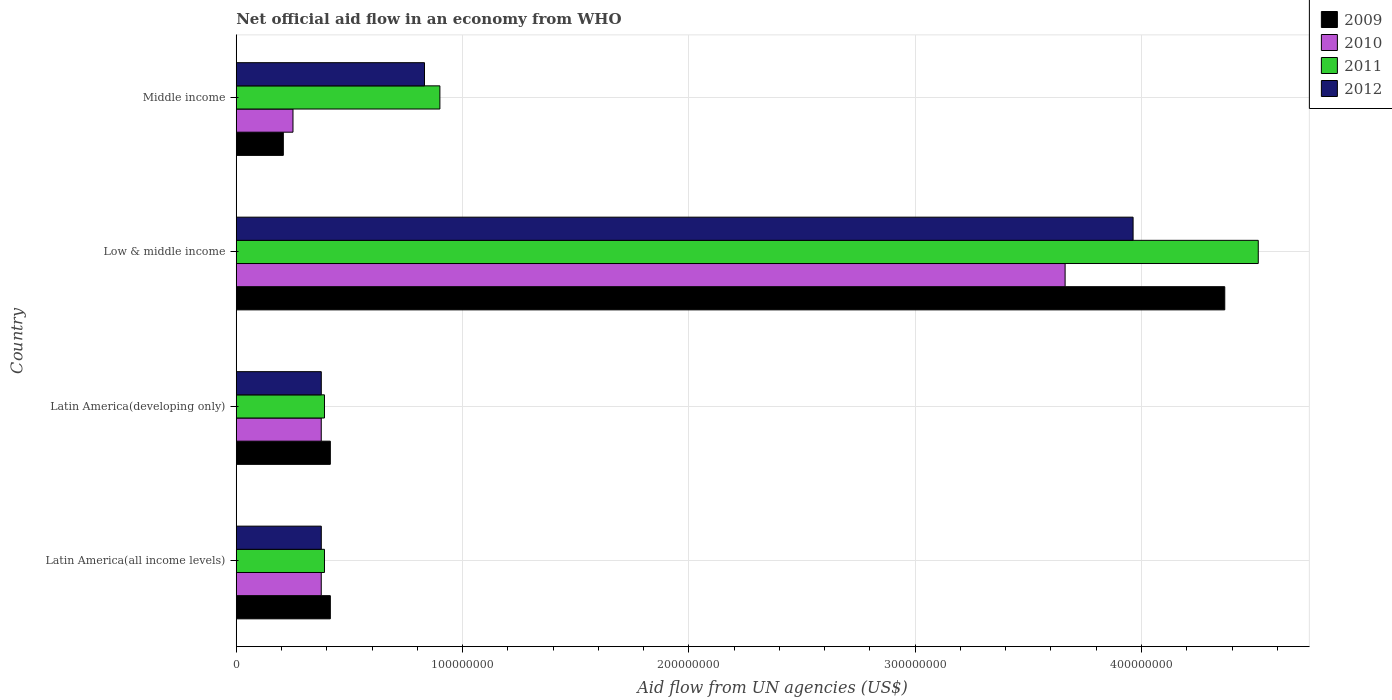How many different coloured bars are there?
Provide a succinct answer. 4. Are the number of bars on each tick of the Y-axis equal?
Give a very brief answer. Yes. How many bars are there on the 4th tick from the top?
Offer a very short reply. 4. How many bars are there on the 3rd tick from the bottom?
Offer a terse response. 4. What is the net official aid flow in 2012 in Latin America(all income levels)?
Ensure brevity in your answer.  3.76e+07. Across all countries, what is the maximum net official aid flow in 2011?
Your answer should be very brief. 4.52e+08. Across all countries, what is the minimum net official aid flow in 2009?
Provide a succinct answer. 2.08e+07. In which country was the net official aid flow in 2010 maximum?
Provide a short and direct response. Low & middle income. In which country was the net official aid flow in 2012 minimum?
Your response must be concise. Latin America(all income levels). What is the total net official aid flow in 2011 in the graph?
Your answer should be compact. 6.20e+08. What is the difference between the net official aid flow in 2012 in Latin America(all income levels) and that in Latin America(developing only)?
Your response must be concise. 0. What is the difference between the net official aid flow in 2012 in Latin America(developing only) and the net official aid flow in 2011 in Middle income?
Your answer should be very brief. -5.24e+07. What is the average net official aid flow in 2009 per country?
Offer a terse response. 1.35e+08. What is the difference between the net official aid flow in 2011 and net official aid flow in 2009 in Latin America(all income levels)?
Offer a terse response. -2.59e+06. What is the ratio of the net official aid flow in 2010 in Low & middle income to that in Middle income?
Provide a succinct answer. 14.61. Is the difference between the net official aid flow in 2011 in Low & middle income and Middle income greater than the difference between the net official aid flow in 2009 in Low & middle income and Middle income?
Provide a succinct answer. No. What is the difference between the highest and the second highest net official aid flow in 2011?
Keep it short and to the point. 3.62e+08. What is the difference between the highest and the lowest net official aid flow in 2010?
Offer a terse response. 3.41e+08. Is the sum of the net official aid flow in 2012 in Latin America(developing only) and Low & middle income greater than the maximum net official aid flow in 2010 across all countries?
Provide a succinct answer. Yes. What does the 1st bar from the bottom in Middle income represents?
Offer a very short reply. 2009. Is it the case that in every country, the sum of the net official aid flow in 2011 and net official aid flow in 2009 is greater than the net official aid flow in 2012?
Provide a succinct answer. Yes. Are all the bars in the graph horizontal?
Your response must be concise. Yes. How many countries are there in the graph?
Your answer should be very brief. 4. Are the values on the major ticks of X-axis written in scientific E-notation?
Provide a short and direct response. No. How are the legend labels stacked?
Make the answer very short. Vertical. What is the title of the graph?
Keep it short and to the point. Net official aid flow in an economy from WHO. What is the label or title of the X-axis?
Your answer should be very brief. Aid flow from UN agencies (US$). What is the Aid flow from UN agencies (US$) of 2009 in Latin America(all income levels)?
Give a very brief answer. 4.16e+07. What is the Aid flow from UN agencies (US$) in 2010 in Latin America(all income levels)?
Offer a terse response. 3.76e+07. What is the Aid flow from UN agencies (US$) in 2011 in Latin America(all income levels)?
Offer a very short reply. 3.90e+07. What is the Aid flow from UN agencies (US$) in 2012 in Latin America(all income levels)?
Make the answer very short. 3.76e+07. What is the Aid flow from UN agencies (US$) in 2009 in Latin America(developing only)?
Provide a succinct answer. 4.16e+07. What is the Aid flow from UN agencies (US$) in 2010 in Latin America(developing only)?
Provide a succinct answer. 3.76e+07. What is the Aid flow from UN agencies (US$) of 2011 in Latin America(developing only)?
Your answer should be compact. 3.90e+07. What is the Aid flow from UN agencies (US$) of 2012 in Latin America(developing only)?
Offer a very short reply. 3.76e+07. What is the Aid flow from UN agencies (US$) in 2009 in Low & middle income?
Keep it short and to the point. 4.37e+08. What is the Aid flow from UN agencies (US$) in 2010 in Low & middle income?
Your answer should be very brief. 3.66e+08. What is the Aid flow from UN agencies (US$) in 2011 in Low & middle income?
Offer a terse response. 4.52e+08. What is the Aid flow from UN agencies (US$) of 2012 in Low & middle income?
Make the answer very short. 3.96e+08. What is the Aid flow from UN agencies (US$) of 2009 in Middle income?
Give a very brief answer. 2.08e+07. What is the Aid flow from UN agencies (US$) of 2010 in Middle income?
Offer a terse response. 2.51e+07. What is the Aid flow from UN agencies (US$) of 2011 in Middle income?
Offer a terse response. 9.00e+07. What is the Aid flow from UN agencies (US$) in 2012 in Middle income?
Ensure brevity in your answer.  8.32e+07. Across all countries, what is the maximum Aid flow from UN agencies (US$) of 2009?
Offer a terse response. 4.37e+08. Across all countries, what is the maximum Aid flow from UN agencies (US$) in 2010?
Make the answer very short. 3.66e+08. Across all countries, what is the maximum Aid flow from UN agencies (US$) in 2011?
Your response must be concise. 4.52e+08. Across all countries, what is the maximum Aid flow from UN agencies (US$) in 2012?
Ensure brevity in your answer.  3.96e+08. Across all countries, what is the minimum Aid flow from UN agencies (US$) of 2009?
Your answer should be very brief. 2.08e+07. Across all countries, what is the minimum Aid flow from UN agencies (US$) of 2010?
Keep it short and to the point. 2.51e+07. Across all countries, what is the minimum Aid flow from UN agencies (US$) of 2011?
Your answer should be very brief. 3.90e+07. Across all countries, what is the minimum Aid flow from UN agencies (US$) in 2012?
Your answer should be compact. 3.76e+07. What is the total Aid flow from UN agencies (US$) in 2009 in the graph?
Offer a terse response. 5.41e+08. What is the total Aid flow from UN agencies (US$) in 2010 in the graph?
Your answer should be very brief. 4.66e+08. What is the total Aid flow from UN agencies (US$) in 2011 in the graph?
Your answer should be very brief. 6.20e+08. What is the total Aid flow from UN agencies (US$) in 2012 in the graph?
Your answer should be compact. 5.55e+08. What is the difference between the Aid flow from UN agencies (US$) of 2009 in Latin America(all income levels) and that in Latin America(developing only)?
Ensure brevity in your answer.  0. What is the difference between the Aid flow from UN agencies (US$) of 2010 in Latin America(all income levels) and that in Latin America(developing only)?
Give a very brief answer. 0. What is the difference between the Aid flow from UN agencies (US$) in 2012 in Latin America(all income levels) and that in Latin America(developing only)?
Your response must be concise. 0. What is the difference between the Aid flow from UN agencies (US$) in 2009 in Latin America(all income levels) and that in Low & middle income?
Make the answer very short. -3.95e+08. What is the difference between the Aid flow from UN agencies (US$) of 2010 in Latin America(all income levels) and that in Low & middle income?
Keep it short and to the point. -3.29e+08. What is the difference between the Aid flow from UN agencies (US$) in 2011 in Latin America(all income levels) and that in Low & middle income?
Offer a terse response. -4.13e+08. What is the difference between the Aid flow from UN agencies (US$) of 2012 in Latin America(all income levels) and that in Low & middle income?
Offer a terse response. -3.59e+08. What is the difference between the Aid flow from UN agencies (US$) of 2009 in Latin America(all income levels) and that in Middle income?
Give a very brief answer. 2.08e+07. What is the difference between the Aid flow from UN agencies (US$) in 2010 in Latin America(all income levels) and that in Middle income?
Your response must be concise. 1.25e+07. What is the difference between the Aid flow from UN agencies (US$) of 2011 in Latin America(all income levels) and that in Middle income?
Offer a very short reply. -5.10e+07. What is the difference between the Aid flow from UN agencies (US$) of 2012 in Latin America(all income levels) and that in Middle income?
Offer a terse response. -4.56e+07. What is the difference between the Aid flow from UN agencies (US$) in 2009 in Latin America(developing only) and that in Low & middle income?
Your answer should be very brief. -3.95e+08. What is the difference between the Aid flow from UN agencies (US$) of 2010 in Latin America(developing only) and that in Low & middle income?
Provide a succinct answer. -3.29e+08. What is the difference between the Aid flow from UN agencies (US$) of 2011 in Latin America(developing only) and that in Low & middle income?
Provide a short and direct response. -4.13e+08. What is the difference between the Aid flow from UN agencies (US$) in 2012 in Latin America(developing only) and that in Low & middle income?
Your answer should be very brief. -3.59e+08. What is the difference between the Aid flow from UN agencies (US$) in 2009 in Latin America(developing only) and that in Middle income?
Provide a short and direct response. 2.08e+07. What is the difference between the Aid flow from UN agencies (US$) of 2010 in Latin America(developing only) and that in Middle income?
Your response must be concise. 1.25e+07. What is the difference between the Aid flow from UN agencies (US$) in 2011 in Latin America(developing only) and that in Middle income?
Offer a terse response. -5.10e+07. What is the difference between the Aid flow from UN agencies (US$) in 2012 in Latin America(developing only) and that in Middle income?
Make the answer very short. -4.56e+07. What is the difference between the Aid flow from UN agencies (US$) of 2009 in Low & middle income and that in Middle income?
Offer a terse response. 4.16e+08. What is the difference between the Aid flow from UN agencies (US$) in 2010 in Low & middle income and that in Middle income?
Your answer should be very brief. 3.41e+08. What is the difference between the Aid flow from UN agencies (US$) of 2011 in Low & middle income and that in Middle income?
Your response must be concise. 3.62e+08. What is the difference between the Aid flow from UN agencies (US$) in 2012 in Low & middle income and that in Middle income?
Provide a succinct answer. 3.13e+08. What is the difference between the Aid flow from UN agencies (US$) of 2009 in Latin America(all income levels) and the Aid flow from UN agencies (US$) of 2010 in Latin America(developing only)?
Offer a terse response. 4.01e+06. What is the difference between the Aid flow from UN agencies (US$) in 2009 in Latin America(all income levels) and the Aid flow from UN agencies (US$) in 2011 in Latin America(developing only)?
Make the answer very short. 2.59e+06. What is the difference between the Aid flow from UN agencies (US$) in 2009 in Latin America(all income levels) and the Aid flow from UN agencies (US$) in 2012 in Latin America(developing only)?
Provide a succinct answer. 3.99e+06. What is the difference between the Aid flow from UN agencies (US$) of 2010 in Latin America(all income levels) and the Aid flow from UN agencies (US$) of 2011 in Latin America(developing only)?
Provide a succinct answer. -1.42e+06. What is the difference between the Aid flow from UN agencies (US$) in 2010 in Latin America(all income levels) and the Aid flow from UN agencies (US$) in 2012 in Latin America(developing only)?
Offer a very short reply. -2.00e+04. What is the difference between the Aid flow from UN agencies (US$) of 2011 in Latin America(all income levels) and the Aid flow from UN agencies (US$) of 2012 in Latin America(developing only)?
Your answer should be very brief. 1.40e+06. What is the difference between the Aid flow from UN agencies (US$) in 2009 in Latin America(all income levels) and the Aid flow from UN agencies (US$) in 2010 in Low & middle income?
Your answer should be compact. -3.25e+08. What is the difference between the Aid flow from UN agencies (US$) of 2009 in Latin America(all income levels) and the Aid flow from UN agencies (US$) of 2011 in Low & middle income?
Provide a short and direct response. -4.10e+08. What is the difference between the Aid flow from UN agencies (US$) of 2009 in Latin America(all income levels) and the Aid flow from UN agencies (US$) of 2012 in Low & middle income?
Provide a succinct answer. -3.55e+08. What is the difference between the Aid flow from UN agencies (US$) of 2010 in Latin America(all income levels) and the Aid flow from UN agencies (US$) of 2011 in Low & middle income?
Offer a terse response. -4.14e+08. What is the difference between the Aid flow from UN agencies (US$) in 2010 in Latin America(all income levels) and the Aid flow from UN agencies (US$) in 2012 in Low & middle income?
Offer a terse response. -3.59e+08. What is the difference between the Aid flow from UN agencies (US$) in 2011 in Latin America(all income levels) and the Aid flow from UN agencies (US$) in 2012 in Low & middle income?
Your response must be concise. -3.57e+08. What is the difference between the Aid flow from UN agencies (US$) in 2009 in Latin America(all income levels) and the Aid flow from UN agencies (US$) in 2010 in Middle income?
Ensure brevity in your answer.  1.65e+07. What is the difference between the Aid flow from UN agencies (US$) of 2009 in Latin America(all income levels) and the Aid flow from UN agencies (US$) of 2011 in Middle income?
Offer a very short reply. -4.84e+07. What is the difference between the Aid flow from UN agencies (US$) in 2009 in Latin America(all income levels) and the Aid flow from UN agencies (US$) in 2012 in Middle income?
Your answer should be very brief. -4.16e+07. What is the difference between the Aid flow from UN agencies (US$) of 2010 in Latin America(all income levels) and the Aid flow from UN agencies (US$) of 2011 in Middle income?
Your answer should be very brief. -5.24e+07. What is the difference between the Aid flow from UN agencies (US$) of 2010 in Latin America(all income levels) and the Aid flow from UN agencies (US$) of 2012 in Middle income?
Provide a short and direct response. -4.56e+07. What is the difference between the Aid flow from UN agencies (US$) of 2011 in Latin America(all income levels) and the Aid flow from UN agencies (US$) of 2012 in Middle income?
Your answer should be compact. -4.42e+07. What is the difference between the Aid flow from UN agencies (US$) in 2009 in Latin America(developing only) and the Aid flow from UN agencies (US$) in 2010 in Low & middle income?
Provide a short and direct response. -3.25e+08. What is the difference between the Aid flow from UN agencies (US$) of 2009 in Latin America(developing only) and the Aid flow from UN agencies (US$) of 2011 in Low & middle income?
Give a very brief answer. -4.10e+08. What is the difference between the Aid flow from UN agencies (US$) in 2009 in Latin America(developing only) and the Aid flow from UN agencies (US$) in 2012 in Low & middle income?
Your answer should be compact. -3.55e+08. What is the difference between the Aid flow from UN agencies (US$) of 2010 in Latin America(developing only) and the Aid flow from UN agencies (US$) of 2011 in Low & middle income?
Give a very brief answer. -4.14e+08. What is the difference between the Aid flow from UN agencies (US$) in 2010 in Latin America(developing only) and the Aid flow from UN agencies (US$) in 2012 in Low & middle income?
Your response must be concise. -3.59e+08. What is the difference between the Aid flow from UN agencies (US$) of 2011 in Latin America(developing only) and the Aid flow from UN agencies (US$) of 2012 in Low & middle income?
Your answer should be compact. -3.57e+08. What is the difference between the Aid flow from UN agencies (US$) in 2009 in Latin America(developing only) and the Aid flow from UN agencies (US$) in 2010 in Middle income?
Your answer should be compact. 1.65e+07. What is the difference between the Aid flow from UN agencies (US$) of 2009 in Latin America(developing only) and the Aid flow from UN agencies (US$) of 2011 in Middle income?
Ensure brevity in your answer.  -4.84e+07. What is the difference between the Aid flow from UN agencies (US$) in 2009 in Latin America(developing only) and the Aid flow from UN agencies (US$) in 2012 in Middle income?
Keep it short and to the point. -4.16e+07. What is the difference between the Aid flow from UN agencies (US$) in 2010 in Latin America(developing only) and the Aid flow from UN agencies (US$) in 2011 in Middle income?
Offer a very short reply. -5.24e+07. What is the difference between the Aid flow from UN agencies (US$) of 2010 in Latin America(developing only) and the Aid flow from UN agencies (US$) of 2012 in Middle income?
Ensure brevity in your answer.  -4.56e+07. What is the difference between the Aid flow from UN agencies (US$) in 2011 in Latin America(developing only) and the Aid flow from UN agencies (US$) in 2012 in Middle income?
Offer a terse response. -4.42e+07. What is the difference between the Aid flow from UN agencies (US$) of 2009 in Low & middle income and the Aid flow from UN agencies (US$) of 2010 in Middle income?
Keep it short and to the point. 4.12e+08. What is the difference between the Aid flow from UN agencies (US$) in 2009 in Low & middle income and the Aid flow from UN agencies (US$) in 2011 in Middle income?
Keep it short and to the point. 3.47e+08. What is the difference between the Aid flow from UN agencies (US$) in 2009 in Low & middle income and the Aid flow from UN agencies (US$) in 2012 in Middle income?
Provide a succinct answer. 3.54e+08. What is the difference between the Aid flow from UN agencies (US$) of 2010 in Low & middle income and the Aid flow from UN agencies (US$) of 2011 in Middle income?
Offer a terse response. 2.76e+08. What is the difference between the Aid flow from UN agencies (US$) in 2010 in Low & middle income and the Aid flow from UN agencies (US$) in 2012 in Middle income?
Offer a terse response. 2.83e+08. What is the difference between the Aid flow from UN agencies (US$) of 2011 in Low & middle income and the Aid flow from UN agencies (US$) of 2012 in Middle income?
Ensure brevity in your answer.  3.68e+08. What is the average Aid flow from UN agencies (US$) in 2009 per country?
Make the answer very short. 1.35e+08. What is the average Aid flow from UN agencies (US$) of 2010 per country?
Offer a very short reply. 1.17e+08. What is the average Aid flow from UN agencies (US$) of 2011 per country?
Offer a terse response. 1.55e+08. What is the average Aid flow from UN agencies (US$) of 2012 per country?
Your answer should be compact. 1.39e+08. What is the difference between the Aid flow from UN agencies (US$) of 2009 and Aid flow from UN agencies (US$) of 2010 in Latin America(all income levels)?
Offer a terse response. 4.01e+06. What is the difference between the Aid flow from UN agencies (US$) in 2009 and Aid flow from UN agencies (US$) in 2011 in Latin America(all income levels)?
Keep it short and to the point. 2.59e+06. What is the difference between the Aid flow from UN agencies (US$) of 2009 and Aid flow from UN agencies (US$) of 2012 in Latin America(all income levels)?
Your response must be concise. 3.99e+06. What is the difference between the Aid flow from UN agencies (US$) of 2010 and Aid flow from UN agencies (US$) of 2011 in Latin America(all income levels)?
Your answer should be very brief. -1.42e+06. What is the difference between the Aid flow from UN agencies (US$) in 2010 and Aid flow from UN agencies (US$) in 2012 in Latin America(all income levels)?
Offer a terse response. -2.00e+04. What is the difference between the Aid flow from UN agencies (US$) in 2011 and Aid flow from UN agencies (US$) in 2012 in Latin America(all income levels)?
Ensure brevity in your answer.  1.40e+06. What is the difference between the Aid flow from UN agencies (US$) of 2009 and Aid flow from UN agencies (US$) of 2010 in Latin America(developing only)?
Give a very brief answer. 4.01e+06. What is the difference between the Aid flow from UN agencies (US$) in 2009 and Aid flow from UN agencies (US$) in 2011 in Latin America(developing only)?
Offer a very short reply. 2.59e+06. What is the difference between the Aid flow from UN agencies (US$) in 2009 and Aid flow from UN agencies (US$) in 2012 in Latin America(developing only)?
Make the answer very short. 3.99e+06. What is the difference between the Aid flow from UN agencies (US$) in 2010 and Aid flow from UN agencies (US$) in 2011 in Latin America(developing only)?
Provide a short and direct response. -1.42e+06. What is the difference between the Aid flow from UN agencies (US$) in 2011 and Aid flow from UN agencies (US$) in 2012 in Latin America(developing only)?
Offer a very short reply. 1.40e+06. What is the difference between the Aid flow from UN agencies (US$) in 2009 and Aid flow from UN agencies (US$) in 2010 in Low & middle income?
Provide a short and direct response. 7.06e+07. What is the difference between the Aid flow from UN agencies (US$) of 2009 and Aid flow from UN agencies (US$) of 2011 in Low & middle income?
Ensure brevity in your answer.  -1.48e+07. What is the difference between the Aid flow from UN agencies (US$) of 2009 and Aid flow from UN agencies (US$) of 2012 in Low & middle income?
Provide a succinct answer. 4.05e+07. What is the difference between the Aid flow from UN agencies (US$) of 2010 and Aid flow from UN agencies (US$) of 2011 in Low & middle income?
Offer a very short reply. -8.54e+07. What is the difference between the Aid flow from UN agencies (US$) in 2010 and Aid flow from UN agencies (US$) in 2012 in Low & middle income?
Your response must be concise. -3.00e+07. What is the difference between the Aid flow from UN agencies (US$) in 2011 and Aid flow from UN agencies (US$) in 2012 in Low & middle income?
Ensure brevity in your answer.  5.53e+07. What is the difference between the Aid flow from UN agencies (US$) in 2009 and Aid flow from UN agencies (US$) in 2010 in Middle income?
Ensure brevity in your answer.  -4.27e+06. What is the difference between the Aid flow from UN agencies (US$) of 2009 and Aid flow from UN agencies (US$) of 2011 in Middle income?
Ensure brevity in your answer.  -6.92e+07. What is the difference between the Aid flow from UN agencies (US$) of 2009 and Aid flow from UN agencies (US$) of 2012 in Middle income?
Your answer should be compact. -6.24e+07. What is the difference between the Aid flow from UN agencies (US$) in 2010 and Aid flow from UN agencies (US$) in 2011 in Middle income?
Provide a short and direct response. -6.49e+07. What is the difference between the Aid flow from UN agencies (US$) in 2010 and Aid flow from UN agencies (US$) in 2012 in Middle income?
Offer a terse response. -5.81e+07. What is the difference between the Aid flow from UN agencies (US$) of 2011 and Aid flow from UN agencies (US$) of 2012 in Middle income?
Your answer should be compact. 6.80e+06. What is the ratio of the Aid flow from UN agencies (US$) of 2010 in Latin America(all income levels) to that in Latin America(developing only)?
Keep it short and to the point. 1. What is the ratio of the Aid flow from UN agencies (US$) of 2009 in Latin America(all income levels) to that in Low & middle income?
Ensure brevity in your answer.  0.1. What is the ratio of the Aid flow from UN agencies (US$) in 2010 in Latin America(all income levels) to that in Low & middle income?
Make the answer very short. 0.1. What is the ratio of the Aid flow from UN agencies (US$) of 2011 in Latin America(all income levels) to that in Low & middle income?
Give a very brief answer. 0.09. What is the ratio of the Aid flow from UN agencies (US$) of 2012 in Latin America(all income levels) to that in Low & middle income?
Keep it short and to the point. 0.09. What is the ratio of the Aid flow from UN agencies (US$) of 2009 in Latin America(all income levels) to that in Middle income?
Your answer should be very brief. 2. What is the ratio of the Aid flow from UN agencies (US$) of 2010 in Latin America(all income levels) to that in Middle income?
Make the answer very short. 1.5. What is the ratio of the Aid flow from UN agencies (US$) of 2011 in Latin America(all income levels) to that in Middle income?
Provide a short and direct response. 0.43. What is the ratio of the Aid flow from UN agencies (US$) of 2012 in Latin America(all income levels) to that in Middle income?
Your answer should be very brief. 0.45. What is the ratio of the Aid flow from UN agencies (US$) in 2009 in Latin America(developing only) to that in Low & middle income?
Offer a terse response. 0.1. What is the ratio of the Aid flow from UN agencies (US$) of 2010 in Latin America(developing only) to that in Low & middle income?
Keep it short and to the point. 0.1. What is the ratio of the Aid flow from UN agencies (US$) of 2011 in Latin America(developing only) to that in Low & middle income?
Offer a very short reply. 0.09. What is the ratio of the Aid flow from UN agencies (US$) of 2012 in Latin America(developing only) to that in Low & middle income?
Ensure brevity in your answer.  0.09. What is the ratio of the Aid flow from UN agencies (US$) of 2009 in Latin America(developing only) to that in Middle income?
Keep it short and to the point. 2. What is the ratio of the Aid flow from UN agencies (US$) in 2010 in Latin America(developing only) to that in Middle income?
Your answer should be compact. 1.5. What is the ratio of the Aid flow from UN agencies (US$) in 2011 in Latin America(developing only) to that in Middle income?
Make the answer very short. 0.43. What is the ratio of the Aid flow from UN agencies (US$) of 2012 in Latin America(developing only) to that in Middle income?
Your answer should be very brief. 0.45. What is the ratio of the Aid flow from UN agencies (US$) of 2009 in Low & middle income to that in Middle income?
Offer a very short reply. 21. What is the ratio of the Aid flow from UN agencies (US$) of 2010 in Low & middle income to that in Middle income?
Offer a terse response. 14.61. What is the ratio of the Aid flow from UN agencies (US$) in 2011 in Low & middle income to that in Middle income?
Give a very brief answer. 5.02. What is the ratio of the Aid flow from UN agencies (US$) of 2012 in Low & middle income to that in Middle income?
Make the answer very short. 4.76. What is the difference between the highest and the second highest Aid flow from UN agencies (US$) of 2009?
Offer a very short reply. 3.95e+08. What is the difference between the highest and the second highest Aid flow from UN agencies (US$) in 2010?
Your answer should be compact. 3.29e+08. What is the difference between the highest and the second highest Aid flow from UN agencies (US$) of 2011?
Ensure brevity in your answer.  3.62e+08. What is the difference between the highest and the second highest Aid flow from UN agencies (US$) in 2012?
Your answer should be very brief. 3.13e+08. What is the difference between the highest and the lowest Aid flow from UN agencies (US$) in 2009?
Keep it short and to the point. 4.16e+08. What is the difference between the highest and the lowest Aid flow from UN agencies (US$) of 2010?
Your answer should be very brief. 3.41e+08. What is the difference between the highest and the lowest Aid flow from UN agencies (US$) of 2011?
Keep it short and to the point. 4.13e+08. What is the difference between the highest and the lowest Aid flow from UN agencies (US$) of 2012?
Offer a very short reply. 3.59e+08. 